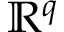<formula> <loc_0><loc_0><loc_500><loc_500>\mathbb { R } ^ { q }</formula> 